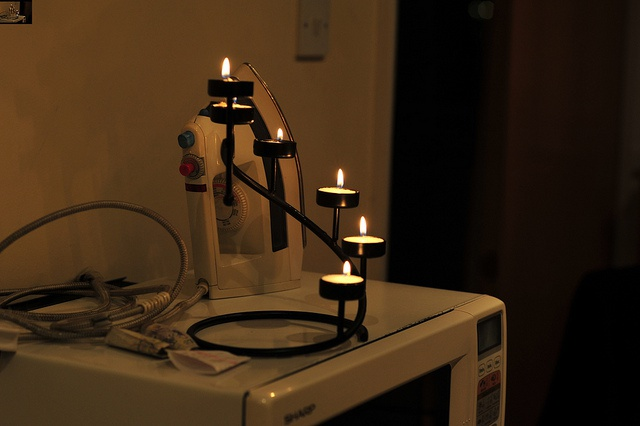Describe the objects in this image and their specific colors. I can see a microwave in black, maroon, and olive tones in this image. 